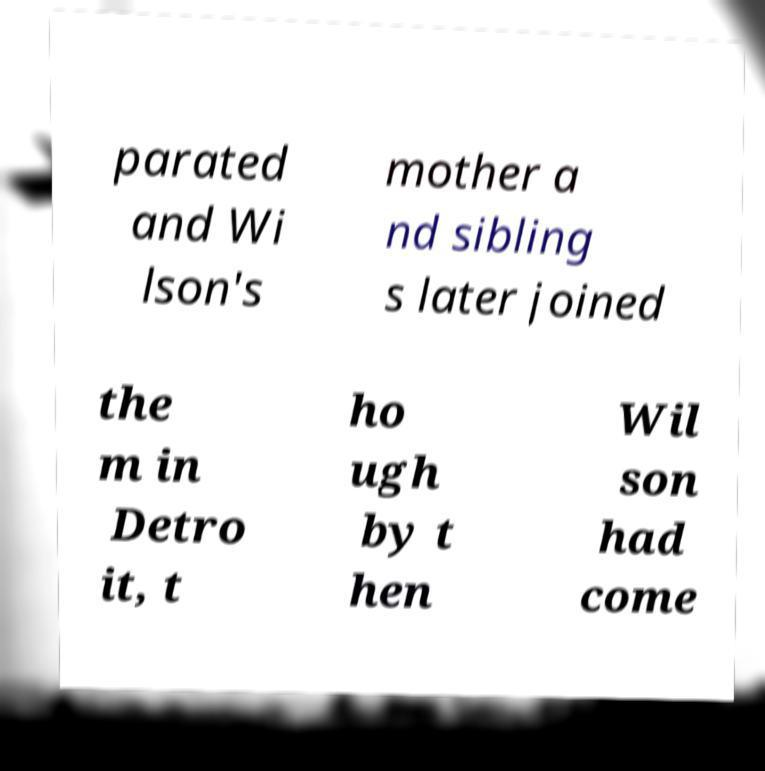Can you accurately transcribe the text from the provided image for me? parated and Wi lson's mother a nd sibling s later joined the m in Detro it, t ho ugh by t hen Wil son had come 